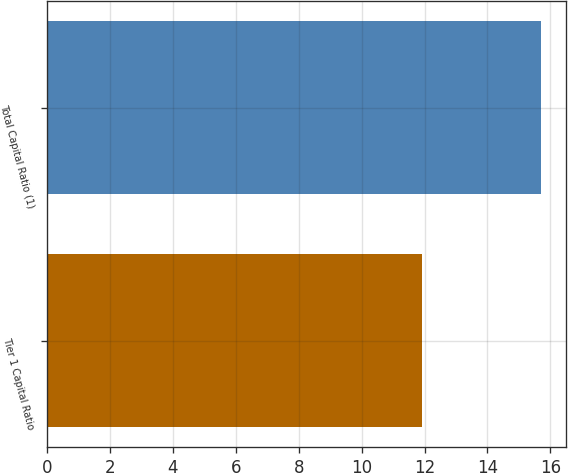<chart> <loc_0><loc_0><loc_500><loc_500><bar_chart><fcel>Tier 1 Capital Ratio<fcel>Total Capital Ratio (1)<nl><fcel>11.92<fcel>15.7<nl></chart> 